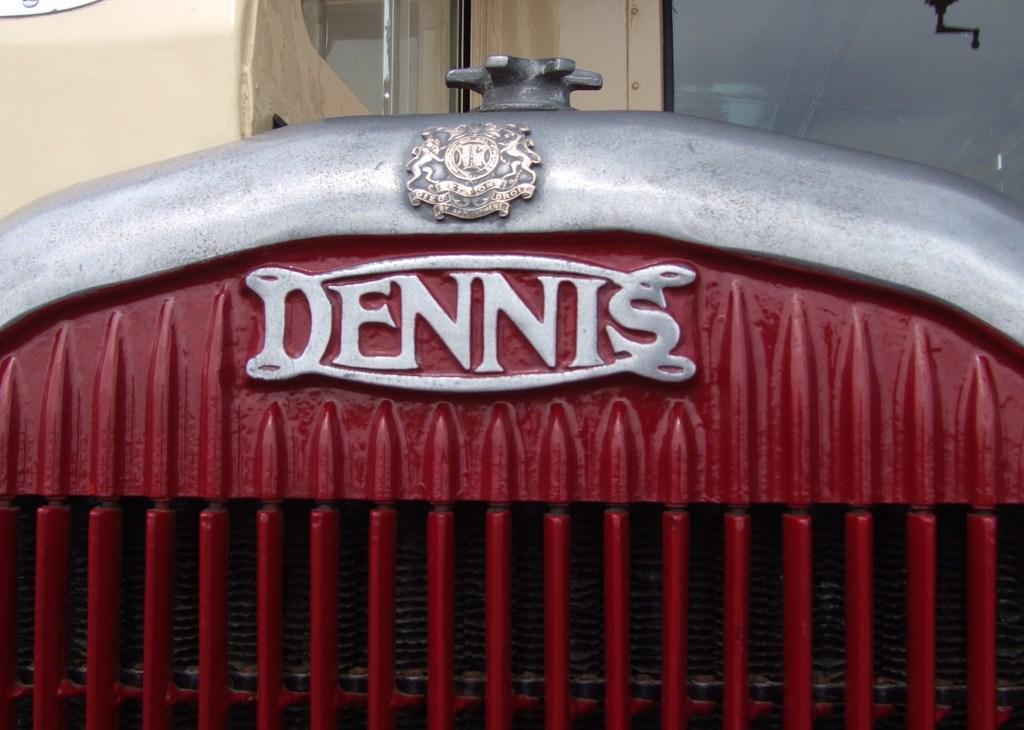In one or two sentences, can you explain what this image depicts? In this image, we can see a metal object with some text. We can also see the wall with some glass. We can also see an object in the top left corner. 